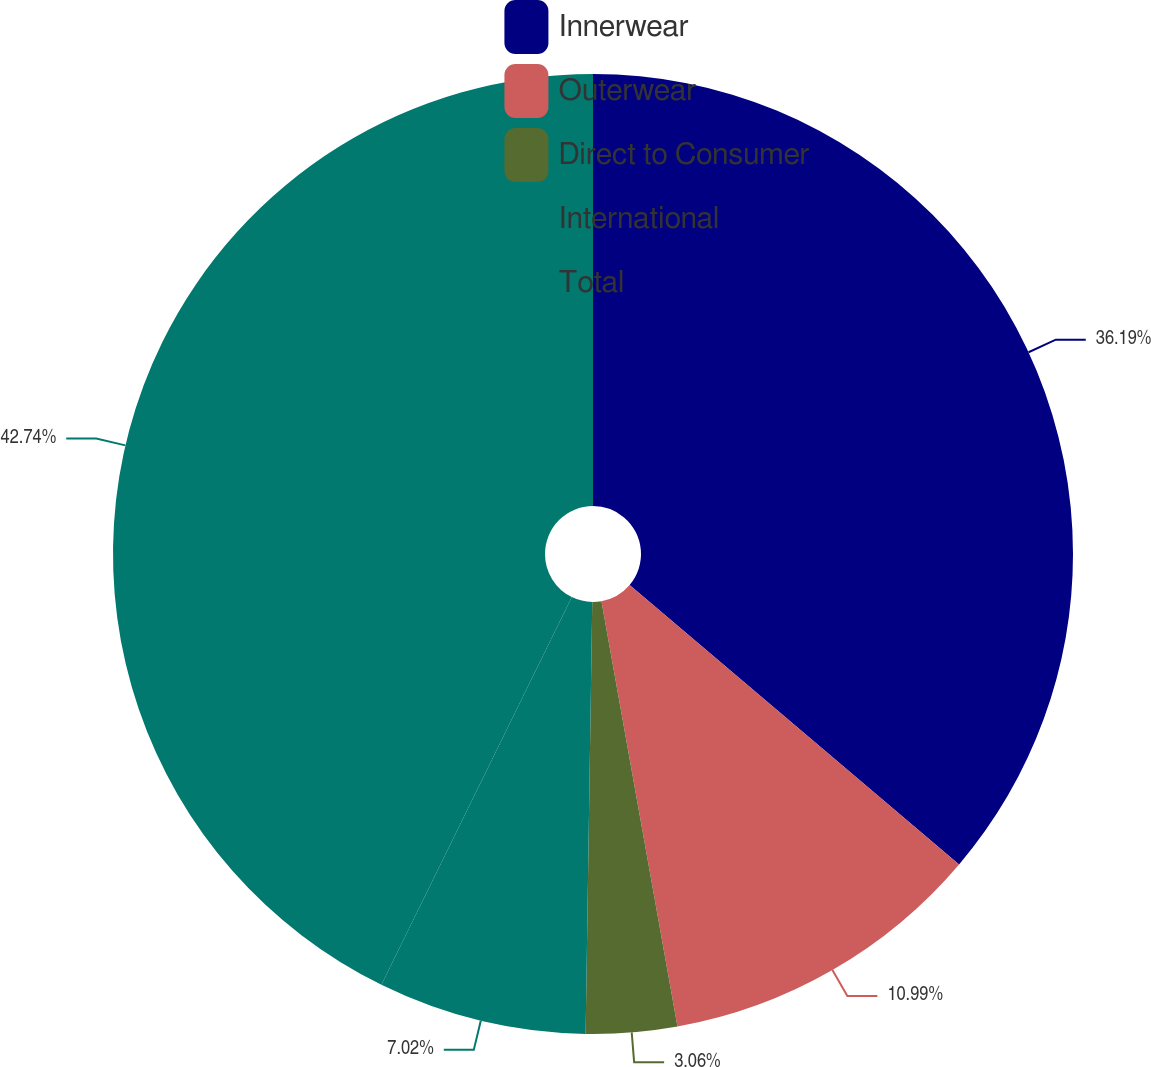<chart> <loc_0><loc_0><loc_500><loc_500><pie_chart><fcel>Innerwear<fcel>Outerwear<fcel>Direct to Consumer<fcel>International<fcel>Total<nl><fcel>36.19%<fcel>10.99%<fcel>3.06%<fcel>7.02%<fcel>42.73%<nl></chart> 